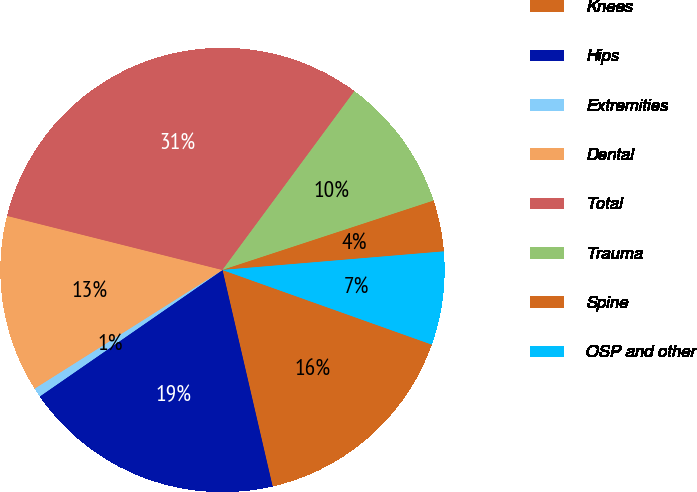Convert chart. <chart><loc_0><loc_0><loc_500><loc_500><pie_chart><fcel>Knees<fcel>Hips<fcel>Extremities<fcel>Dental<fcel>Total<fcel>Trauma<fcel>Spine<fcel>OSP and other<nl><fcel>15.93%<fcel>18.99%<fcel>0.67%<fcel>12.88%<fcel>31.2%<fcel>9.83%<fcel>3.72%<fcel>6.78%<nl></chart> 